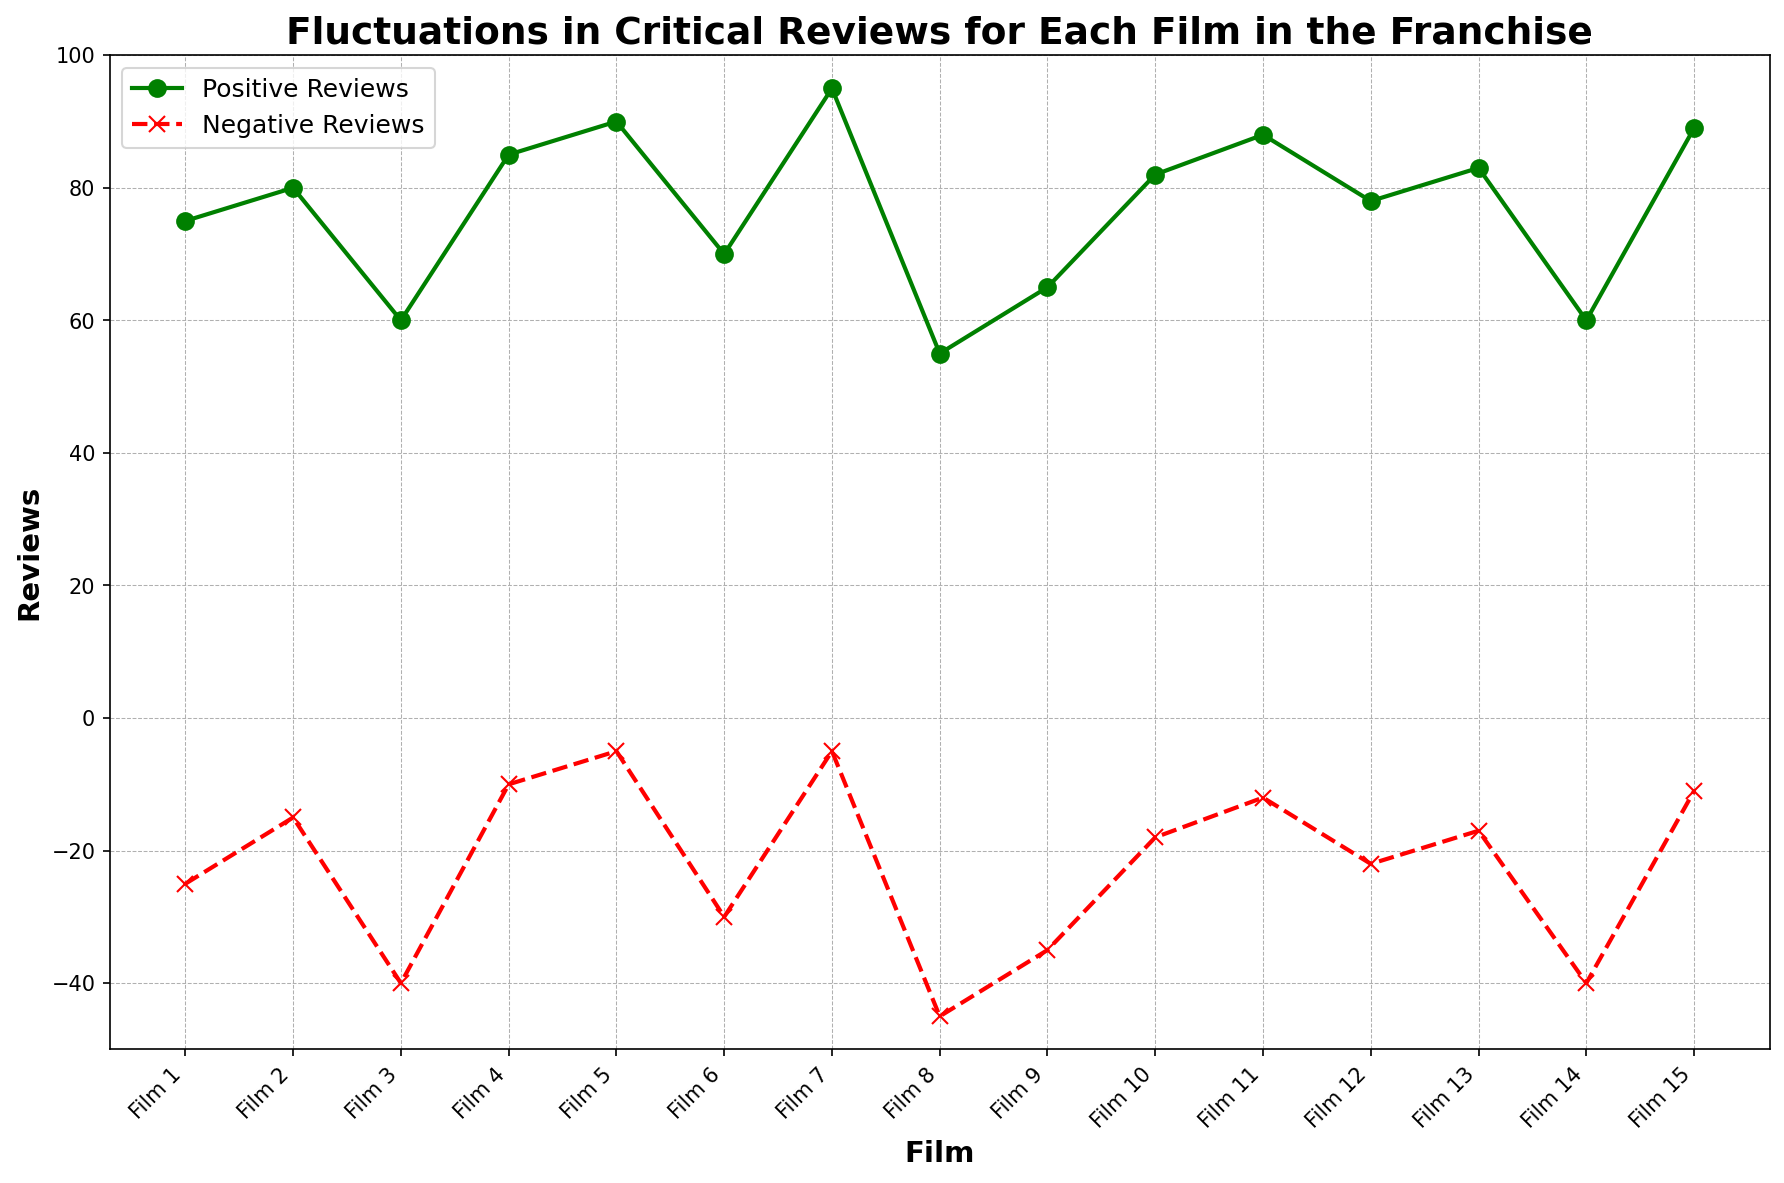How many films received fewer than -20 negative reviews? By examining the negative reviews series on the plot, count the data points that fall below -20.
Answer: 6 Which film has the highest number of positive reviews? Look for the peak value in the positive reviews series on the plot and identify its corresponding film.
Answer: Film 7 For which film is the gap between positive and negative reviews the largest? Calculate the difference between positive and negative reviews for each film, then find the maximum difference. The gap is highest in Film 7 (95 - (-5) = 100).
Answer: Film 7 Compare the positive reviews of Film 8 and Film 14. Which is higher and by how much? Identify the positive reviews for Film 8 and Film 14 from the plot, then subtract Film 14's value from Film 8's. Film 8 has 55 positive reviews and Film 14 has 60, so the difference is 60 - 55.
Answer: Film 14 by 5 reviews What is the average number of positive reviews for the films in the franchise? Sum all the positive reviews and divide by the number of films (15). This requires calculating the sum (75 + 80 + 60 + 85 + 90 + 70 + 95 + 55 + 65 + 82 + 88 + 78 + 83 + 60 + 89 = 1155) and then dividing (1155 / 15).
Answer: 77 Which film has the smallest improvement or decline in reviews compared to the previous film? Calculate the changes in reviews for both positive and negative for consecutive films and compare. Film 9 to Film 10 shows the smallest change in positive reviews (65 to 82 = +17) and negative reviews (-35 to -18 = +17) have similar simple analysis.
Answer: Film 10 How many films have a 'net positive' review score higher than 70? ("Net positive" is positive reviews minus negative reviews) Calculate and count the net positive scores for each film (e.g., Film 1: 75 - (-25) = 100), and then count those greater than 70. Films 8, 9, and 14 do not meet this criterion, while the others do.
Answer: 12 